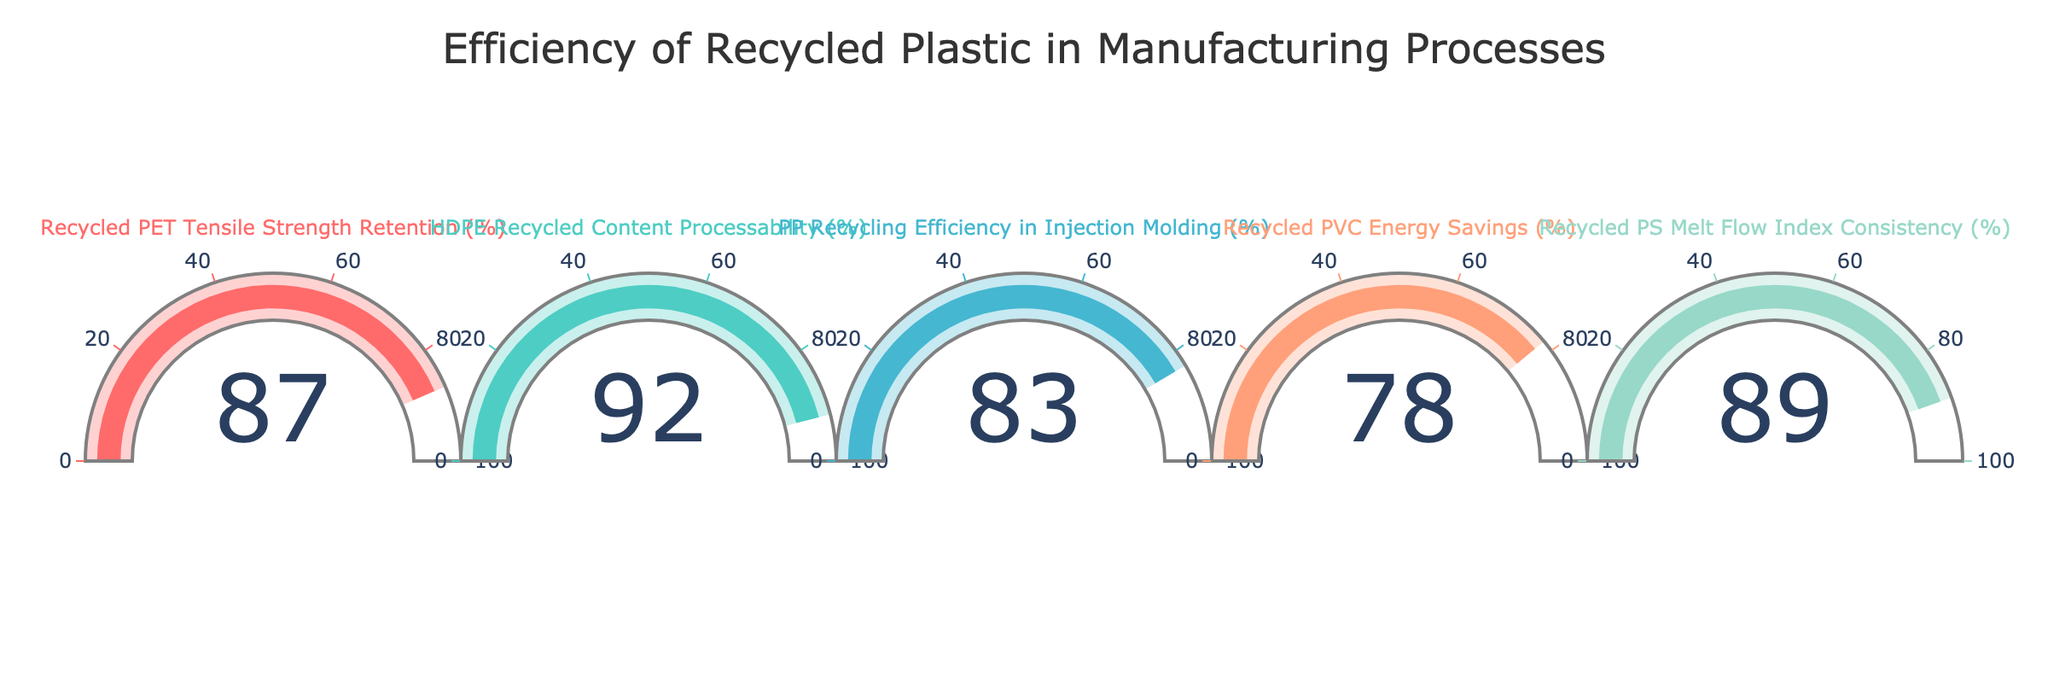What is the value of Recycled PET Tensile Strength Retention? The gauge for Recycled PET Tensile Strength Retention displays a number representing its value.
Answer: 87 How much higher is HDPE Recycled Content Processability compared to PP Recycling Efficiency in Injection Molding? Subtract the value of PP Recycling Efficiency in Injection Molding from the value of HDPE Recycled Content Processability. 92 - 83 = 9
Answer: 9 Which metric has the lowest efficiency value? To determine this, compare all displayed values and identify the smallest one. The values are 87, 92, 83, 78, 89. The lowest is 78.
Answer: Recycled PVC Energy Savings What is the average efficiency value of all the metrics? Sum all the values and then divide by the number of metrics. (87 + 92 + 83 + 78 + 89) / 5 = 429 / 5 = 85.8
Answer: 85.8 Is the efficiency value for Recycled PS Melt Flow Index Consistency greater than that of Recycled PET Tensile Strength Retention? Compare the values of Recycled PS Melt Flow Index Consistency (89) and Recycled PET Tensile Strength Retention (87). Yes, 89 is greater than 87.
Answer: Yes Which metric's efficiency is closest to 80%? Compare each value to 80 to see which one has the smallest difference. The differences are 7, 12, 3, 2, and 9. The smallest difference is 2 for Recycled PVC Energy Savings.
Answer: Recycled PVC Energy Savings What is the combined efficiency value of PP Recycling Efficiency in Injection Molding and Recycled PS Melt Flow Index Consistency? Add the values of PP Recycling Efficiency in Injection Molding (83) and Recycled PS Melt Flow Index Consistency (89). 83 + 89 = 172
Answer: 172 Which two metrics have the most similar efficiency values? Calculate the absolute differences between all pairs of values and find the smallest difference. The smallest difference is between Recycled PET Tensile Strength Retention (87) and Recycled PS Melt Flow Index Consistency (89), which gives 2.
Answer: Recycled PET Tensile Strength Retention and Recycled PS Melt Flow Index Consistency 